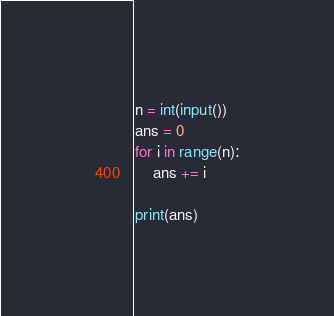Convert code to text. <code><loc_0><loc_0><loc_500><loc_500><_Python_>n = int(input())
ans = 0
for i in range(n):
    ans += i

print(ans)</code> 